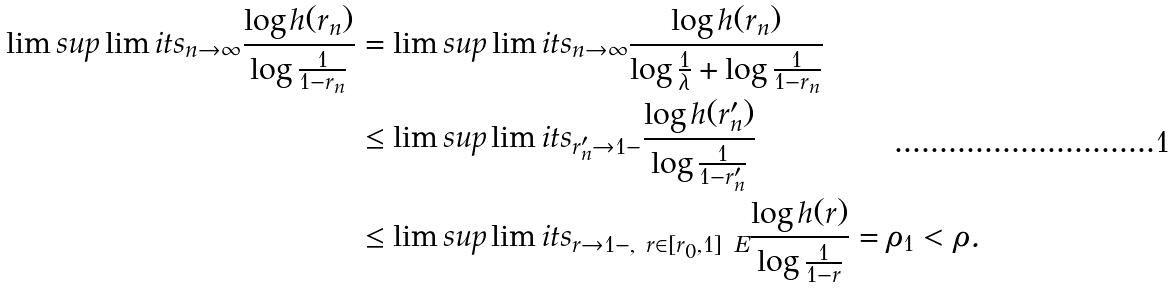Convert formula to latex. <formula><loc_0><loc_0><loc_500><loc_500>\lim s u p \lim i t s _ { n \rightarrow \infty } \frac { \log h ( r _ { n } ) } { \log \frac { 1 } { 1 - r _ { n } } } & = \lim s u p \lim i t s _ { n \rightarrow \infty } \frac { \log h ( r _ { n } ) } { \log \frac { 1 } { \lambda } + \log \frac { 1 } { 1 - r _ { n } } } \\ & \leq \lim s u p \lim i t s _ { r _ { n } ^ { \prime } \rightarrow 1 - } \frac { \log h ( r _ { n } ^ { \prime } ) } { \log \frac { 1 } { 1 - r _ { n } ^ { \prime } } } \\ & \leq \lim s u p \lim i t s _ { r \rightarrow 1 - , \ r \in [ r _ { 0 } , 1 ] \ E } \frac { \log h ( r ) } { \log \frac { 1 } { 1 - r } } = \rho _ { 1 } < \rho .</formula> 